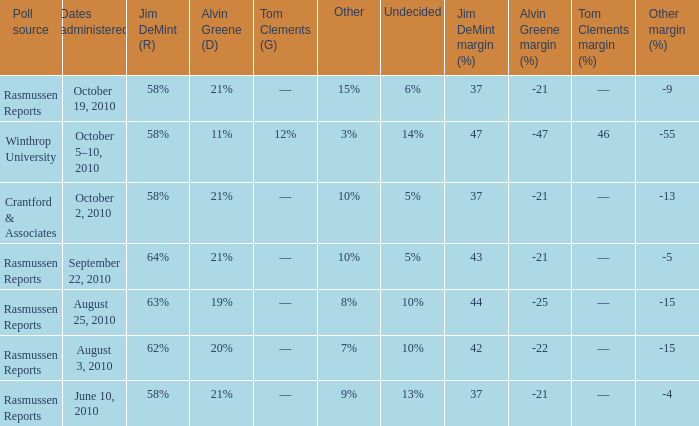What was the vote for Alvin Green when Jim DeMint was 62%? 20%. 